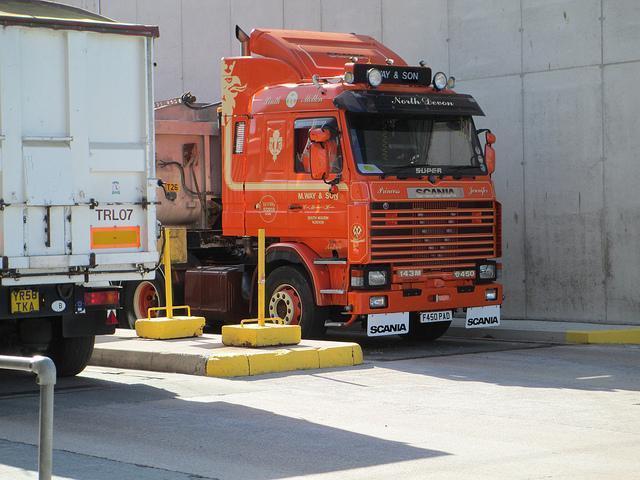How many trucks are there?
Give a very brief answer. 2. How many trucks can be seen?
Give a very brief answer. 2. 